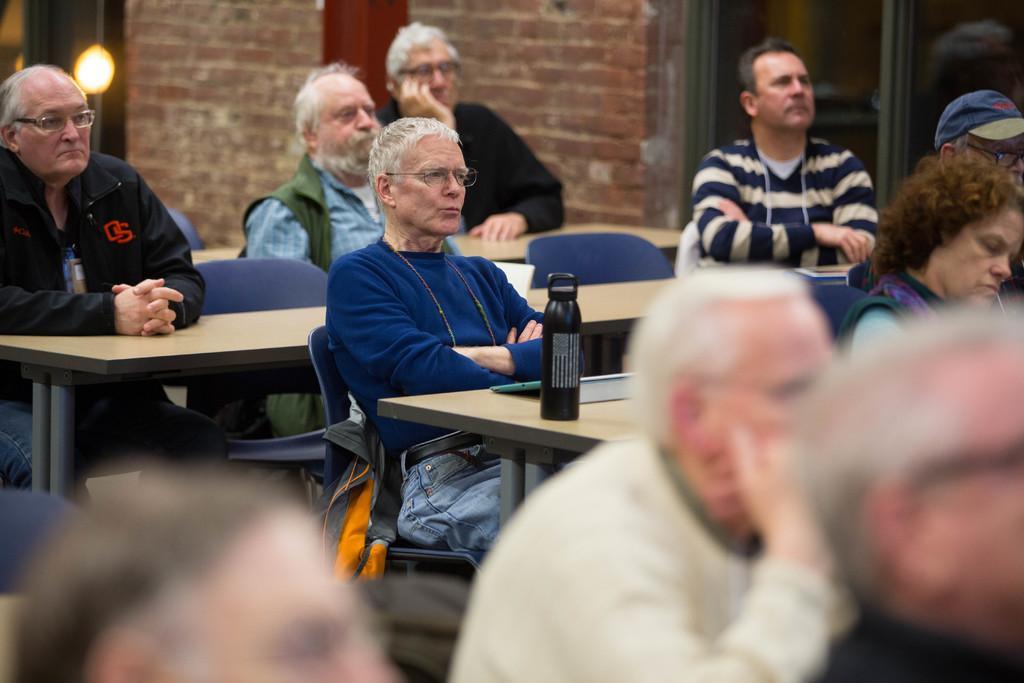Please provide a concise description of this image. There are people sitting on chairs and we can see tables and we can see bottle and object on this table. Background we can see wall,light and glass. 